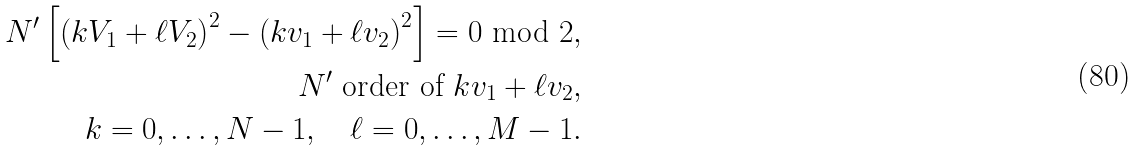<formula> <loc_0><loc_0><loc_500><loc_500>N ^ { \prime } \left [ \left ( k V _ { 1 } + \ell V _ { 2 } \right ) ^ { 2 } - \left ( k v _ { 1 } + \ell v _ { 2 } \right ) ^ { 2 } \right ] = 0 \text { mod } 2 , \\ N ^ { \prime } \text { order of } k v _ { 1 } + \ell v _ { 2 } , \\ k = 0 , \dots , N - 1 , \quad \ell = 0 , \dots , M - 1 .</formula> 